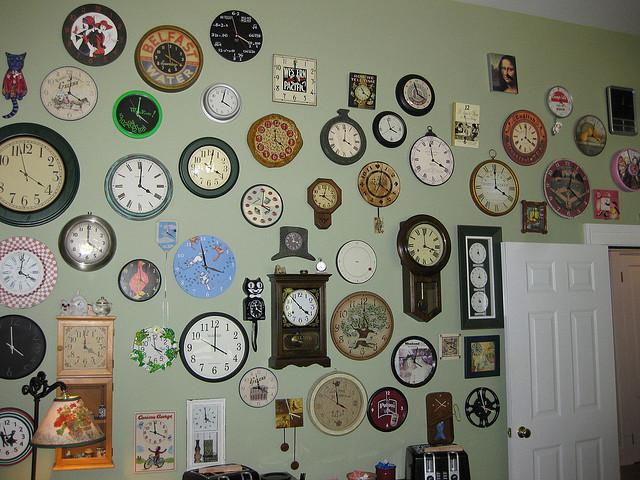Is the door open or closed?
Short answer required. Open. How many clocks?
Be succinct. 55. What country is represented by the top row of clocks?
Short answer required. England. What is covering the wall?
Be succinct. Clocks. How many cat clocks are there?
Give a very brief answer. 2. 